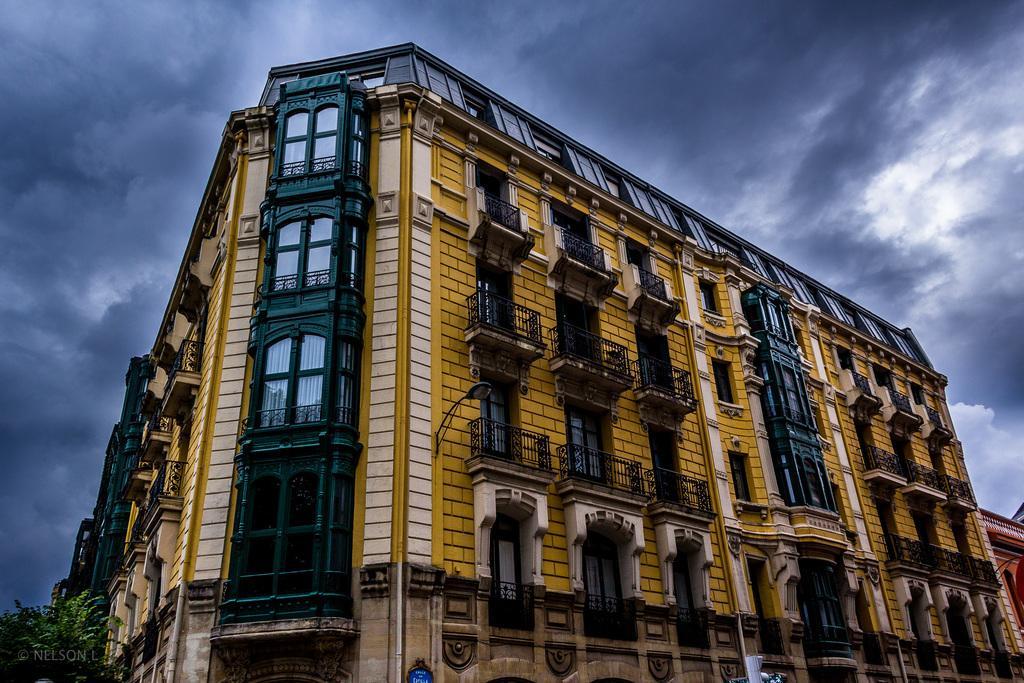In one or two sentences, can you explain what this image depicts? In this picture we can see buildings, leaves, railings, windows and objects. In the background of the image we can see the sky with clouds. In the bottom left side of the image we can see watermark. 